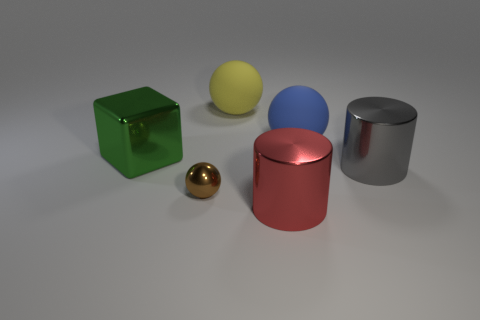What is the color of the block that is made of the same material as the small brown ball?
Your answer should be compact. Green. What is the shape of the big gray object?
Offer a very short reply. Cylinder. What material is the large ball that is in front of the yellow matte object?
Offer a very short reply. Rubber. Is there another large sphere of the same color as the metal sphere?
Ensure brevity in your answer.  No. What is the shape of the green object that is the same size as the red shiny cylinder?
Offer a very short reply. Cube. The sphere that is in front of the metallic block is what color?
Your answer should be compact. Brown. There is a big thing in front of the small ball; is there a tiny brown object in front of it?
Your answer should be compact. No. What number of things are either matte balls left of the big blue thing or matte cylinders?
Provide a succinct answer. 1. Is there anything else that is the same size as the green shiny block?
Your response must be concise. Yes. What material is the thing that is behind the rubber thing that is in front of the yellow object?
Your answer should be very brief. Rubber. 